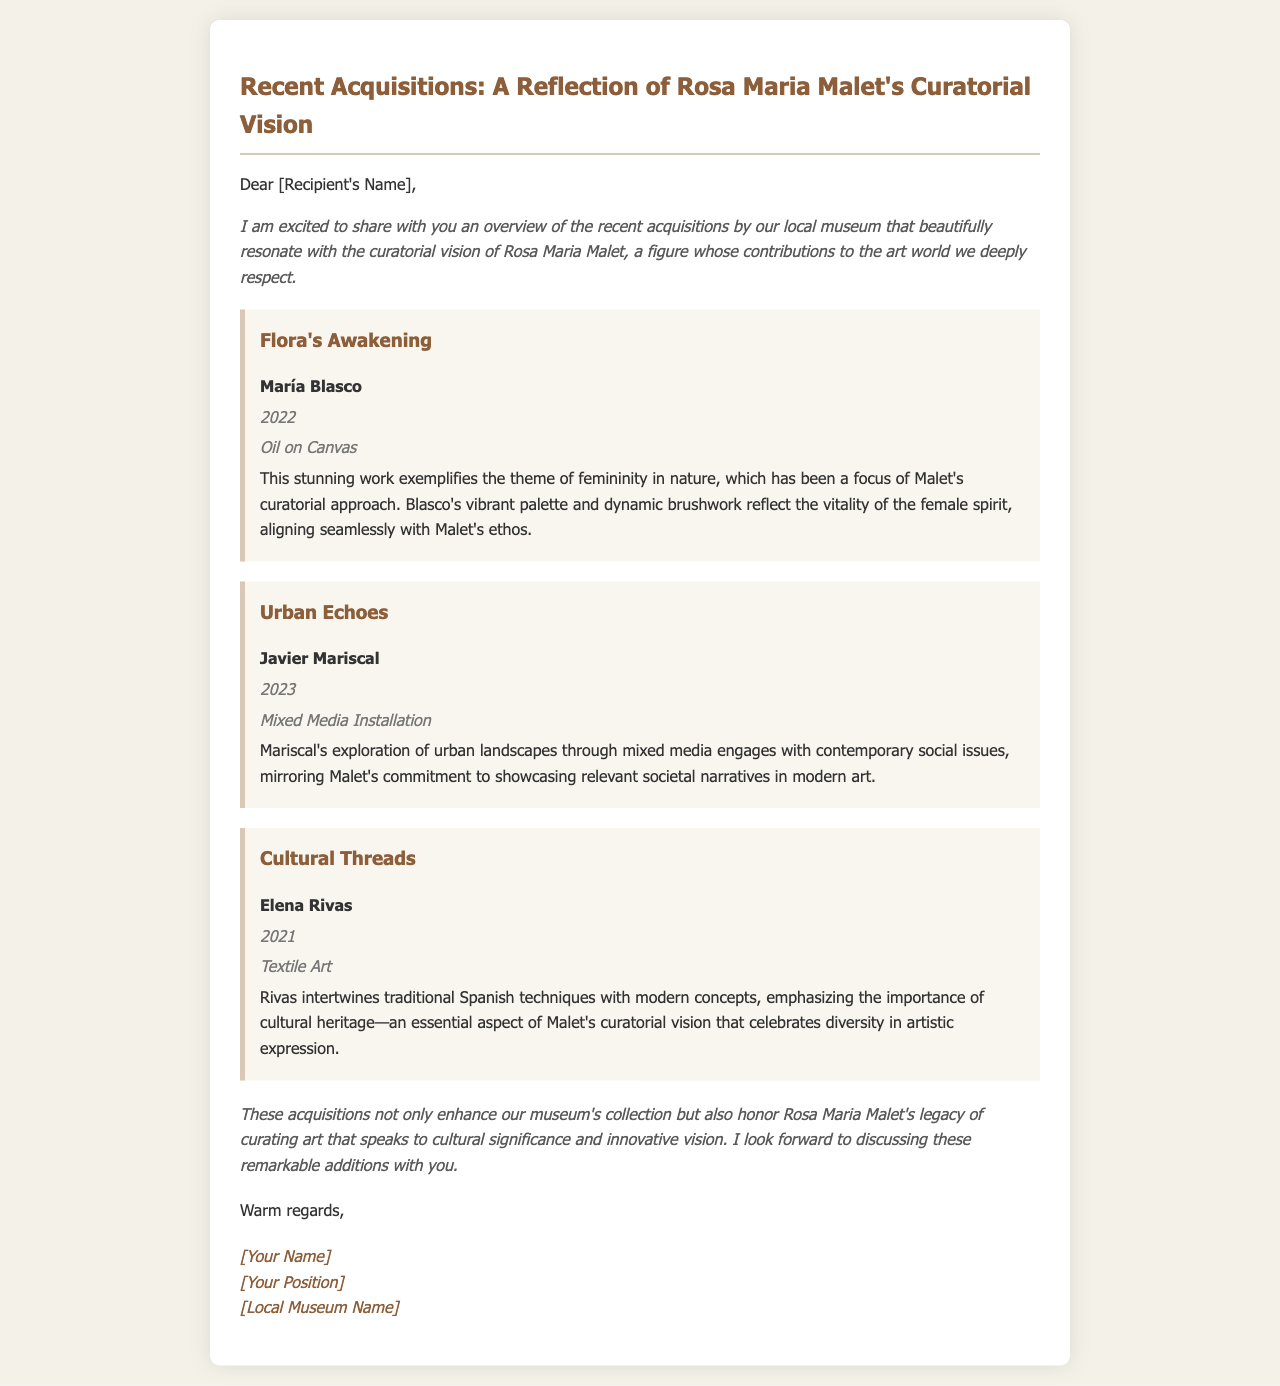What is the title of the email? The title is found in the <title> tag of the HTML document.
Answer: Recent Acquisitions: A Reflection of Rosa Maria Malet's Curatorial Vision Who is the artist of "Flora's Awakening"? The artist's name is listed under the acquisition details for "Flora's Awakening."
Answer: María Blasco In what year was "Urban Echoes" created? The creation year is included in the acquisition details for "Urban Echoes."
Answer: 2023 What medium was used for "Cultural Threads"? The medium is specified in the detail section for "Cultural Threads."
Answer: Textile Art How does "Flora's Awakening" relate to Rosa Maria Malet's curatorial vision? The relationship is explained in the description of "Flora's Awakening," which highlights themes significant to her vision.
Answer: Femininity in nature What are the social issues that "Urban Echoes" addresses? The acquisition details mention that it engages with contemporary social issues, though specifics are not provided.
Answer: Contemporary social issues What overarching theme connects the recent acquisitions? The introductory paragraph hints at a common theme related to curatorial vision.
Answer: Cultural significance What is the tone of the conclusion in the document? The conclusion provides an overall sentiment reflecting on the acquisitions, indicating a positive outlook.
Answer: Positive What type of art is highlighted in the acquisition by Elena Rivas? The type of art is specified in the details of her acquisition section.
Answer: Textile Art 